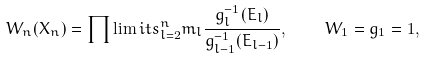<formula> <loc_0><loc_0><loc_500><loc_500>W _ { n } ( { X } _ { n } ) = \prod \lim i t s _ { l = 2 } ^ { n } m _ { l } \frac { g _ { l } ^ { - 1 } ( E _ { l } ) } { g _ { l - 1 } ^ { - 1 } ( E _ { l - 1 } ) } , \quad W _ { 1 } = g _ { 1 } = 1 ,</formula> 